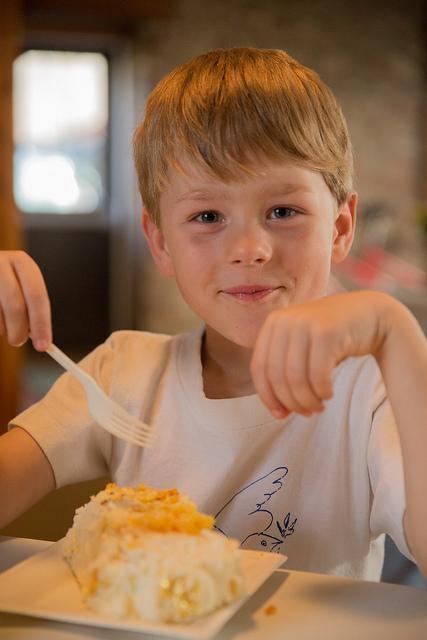How many humans are in the image?
Give a very brief answer. 1. How many elephants are to the right of another elephant?
Give a very brief answer. 0. 